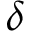<formula> <loc_0><loc_0><loc_500><loc_500>\delta</formula> 